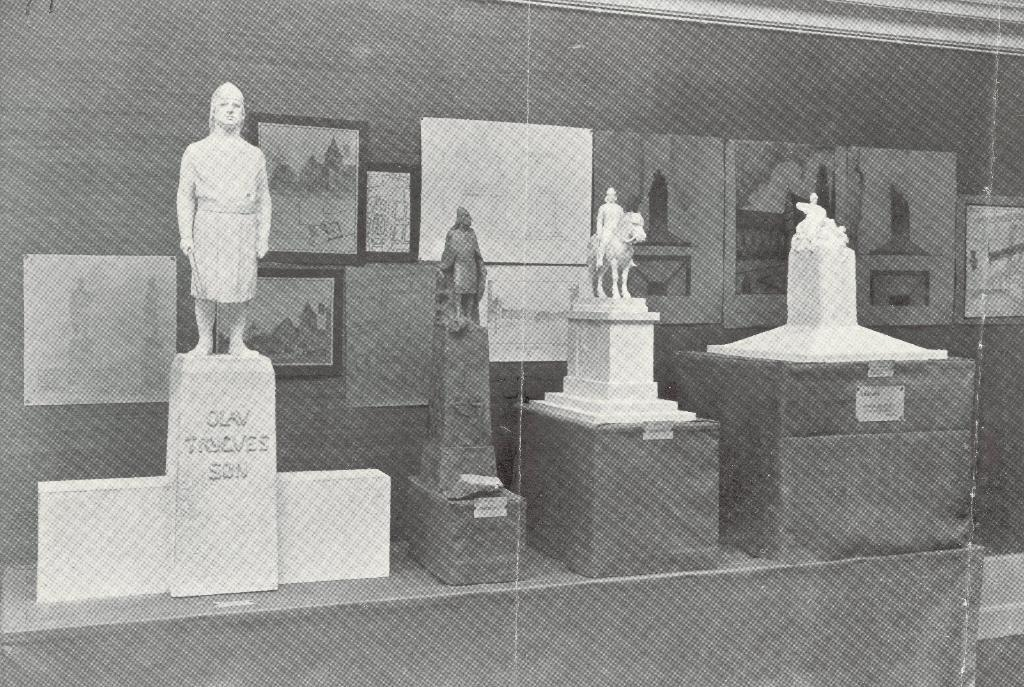What can be seen on the stones in the image? There are sculptures on stones in the image. What is visible in the background of the image? There are frames and a poster on a wall in the background of the image. What type of stove can be seen in the image? There is no stove present in the image. 